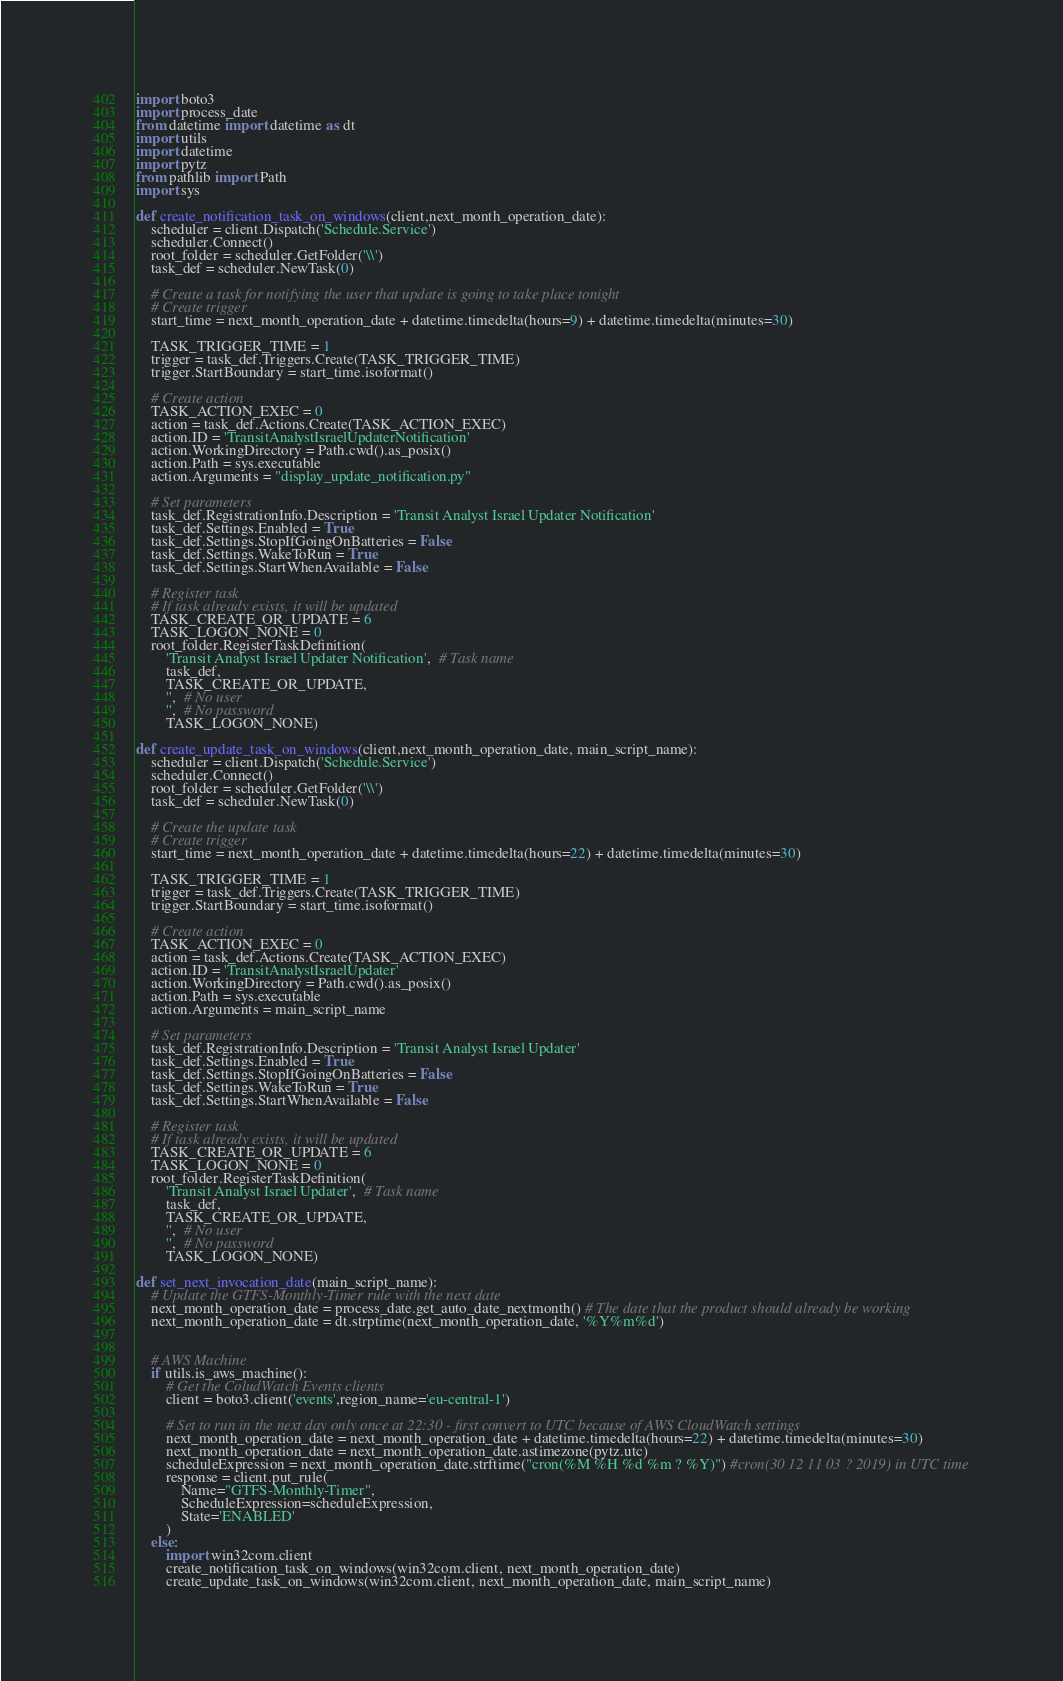<code> <loc_0><loc_0><loc_500><loc_500><_Python_>import boto3
import process_date
from datetime import datetime as dt
import utils
import datetime
import pytz
from pathlib import Path
import sys

def create_notification_task_on_windows(client,next_month_operation_date):
    scheduler = client.Dispatch('Schedule.Service')
    scheduler.Connect()
    root_folder = scheduler.GetFolder('\\')
    task_def = scheduler.NewTask(0)

    # Create a task for notifying the user that update is going to take place tonight
    # Create trigger
    start_time = next_month_operation_date + datetime.timedelta(hours=9) + datetime.timedelta(minutes=30)

    TASK_TRIGGER_TIME = 1
    trigger = task_def.Triggers.Create(TASK_TRIGGER_TIME)
    trigger.StartBoundary = start_time.isoformat()

    # Create action
    TASK_ACTION_EXEC = 0
    action = task_def.Actions.Create(TASK_ACTION_EXEC)
    action.ID = 'TransitAnalystIsraelUpdaterNotification'
    action.WorkingDirectory = Path.cwd().as_posix()
    action.Path = sys.executable
    action.Arguments = "display_update_notification.py"

    # Set parameters
    task_def.RegistrationInfo.Description = 'Transit Analyst Israel Updater Notification'
    task_def.Settings.Enabled = True
    task_def.Settings.StopIfGoingOnBatteries = False
    task_def.Settings.WakeToRun = True
    task_def.Settings.StartWhenAvailable = False

    # Register task
    # If task already exists, it will be updated
    TASK_CREATE_OR_UPDATE = 6
    TASK_LOGON_NONE = 0
    root_folder.RegisterTaskDefinition(
        'Transit Analyst Israel Updater Notification',  # Task name
        task_def,
        TASK_CREATE_OR_UPDATE,
        '',  # No user
        '',  # No password
        TASK_LOGON_NONE)

def create_update_task_on_windows(client,next_month_operation_date, main_script_name):
    scheduler = client.Dispatch('Schedule.Service')
    scheduler.Connect()
    root_folder = scheduler.GetFolder('\\')
    task_def = scheduler.NewTask(0)

    # Create the update task
    # Create trigger
    start_time = next_month_operation_date + datetime.timedelta(hours=22) + datetime.timedelta(minutes=30)

    TASK_TRIGGER_TIME = 1
    trigger = task_def.Triggers.Create(TASK_TRIGGER_TIME)
    trigger.StartBoundary = start_time.isoformat()

    # Create action
    TASK_ACTION_EXEC = 0
    action = task_def.Actions.Create(TASK_ACTION_EXEC)
    action.ID = 'TransitAnalystIsraelUpdater'
    action.WorkingDirectory = Path.cwd().as_posix()
    action.Path = sys.executable
    action.Arguments = main_script_name

    # Set parameters
    task_def.RegistrationInfo.Description = 'Transit Analyst Israel Updater'
    task_def.Settings.Enabled = True
    task_def.Settings.StopIfGoingOnBatteries = False
    task_def.Settings.WakeToRun = True
    task_def.Settings.StartWhenAvailable = False

    # Register task
    # If task already exists, it will be updated
    TASK_CREATE_OR_UPDATE = 6
    TASK_LOGON_NONE = 0
    root_folder.RegisterTaskDefinition(
        'Transit Analyst Israel Updater',  # Task name
        task_def,
        TASK_CREATE_OR_UPDATE,
        '',  # No user
        '',  # No password
        TASK_LOGON_NONE)

def set_next_invocation_date(main_script_name):
    # Update the GTFS-Monthly-Timer rule with the next date
    next_month_operation_date = process_date.get_auto_date_nextmonth() # The date that the product should already be working
    next_month_operation_date = dt.strptime(next_month_operation_date, '%Y%m%d')

    
    # AWS Machine
    if utils.is_aws_machine():
        # Get the ColudWatch Events clients
        client = boto3.client('events',region_name='eu-central-1')

        # Set to run in the next day only once at 22:30 - first convert to UTC because of AWS CloudWatch settings
        next_month_operation_date = next_month_operation_date + datetime.timedelta(hours=22) + datetime.timedelta(minutes=30)
        next_month_operation_date = next_month_operation_date.astimezone(pytz.utc)
        scheduleExpression = next_month_operation_date.strftime("cron(%M %H %d %m ? %Y)") #cron(30 12 11 03 ? 2019) in UTC time
        response = client.put_rule(
            Name="GTFS-Monthly-Timer",
            ScheduleExpression=scheduleExpression,
            State='ENABLED'
        )
    else:
        import win32com.client
        create_notification_task_on_windows(win32com.client, next_month_operation_date)
        create_update_task_on_windows(win32com.client, next_month_operation_date, main_script_name)


</code> 